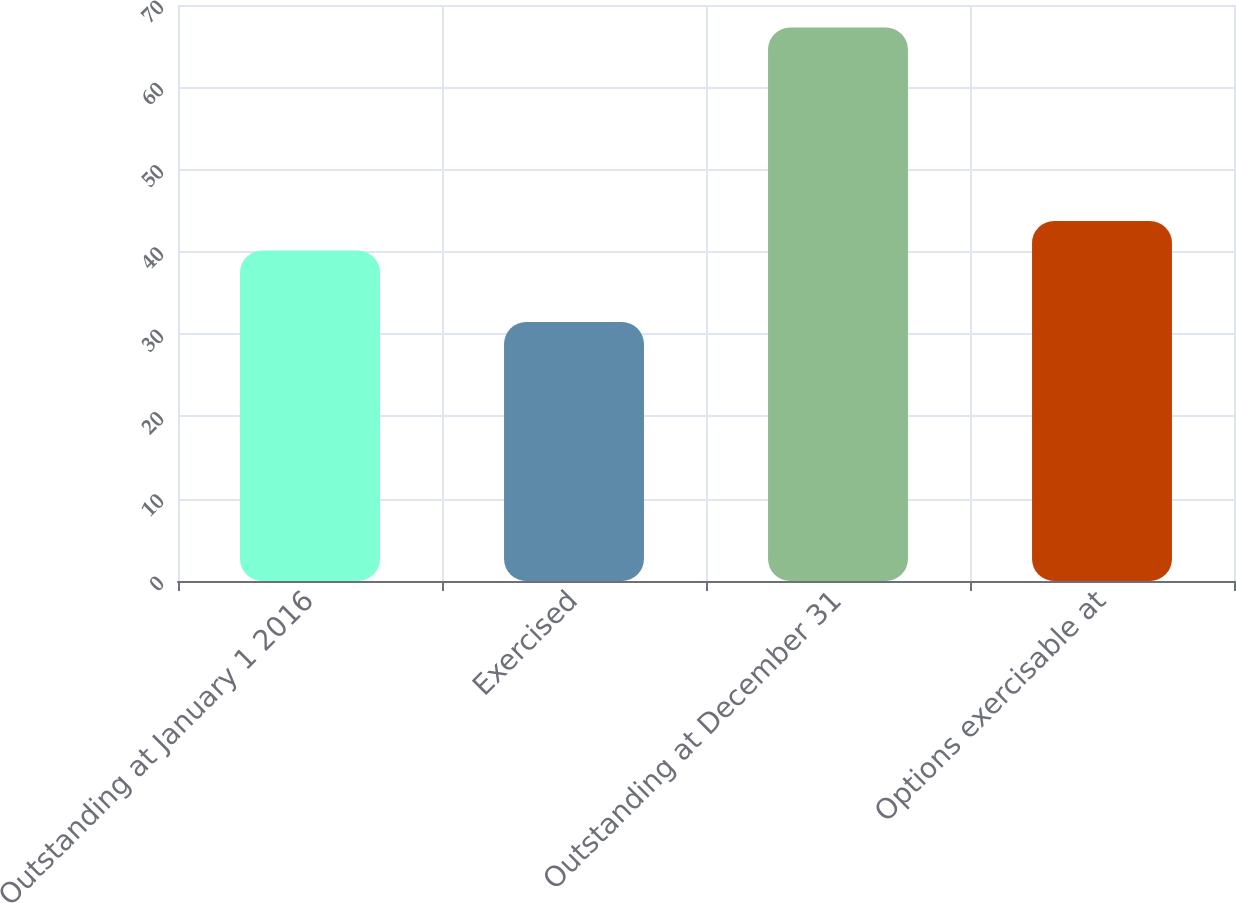Convert chart. <chart><loc_0><loc_0><loc_500><loc_500><bar_chart><fcel>Outstanding at January 1 2016<fcel>Exercised<fcel>Outstanding at December 31<fcel>Options exercisable at<nl><fcel>40.17<fcel>31.47<fcel>67.27<fcel>43.75<nl></chart> 